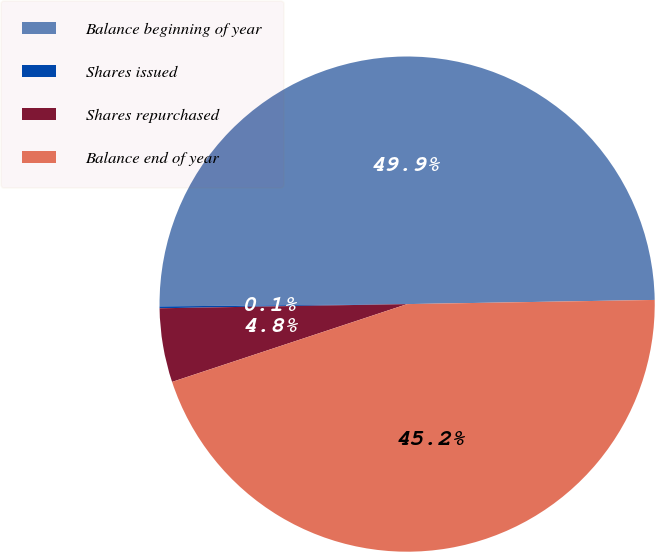Convert chart. <chart><loc_0><loc_0><loc_500><loc_500><pie_chart><fcel>Balance beginning of year<fcel>Shares issued<fcel>Shares repurchased<fcel>Balance end of year<nl><fcel>49.88%<fcel>0.12%<fcel>4.82%<fcel>45.18%<nl></chart> 